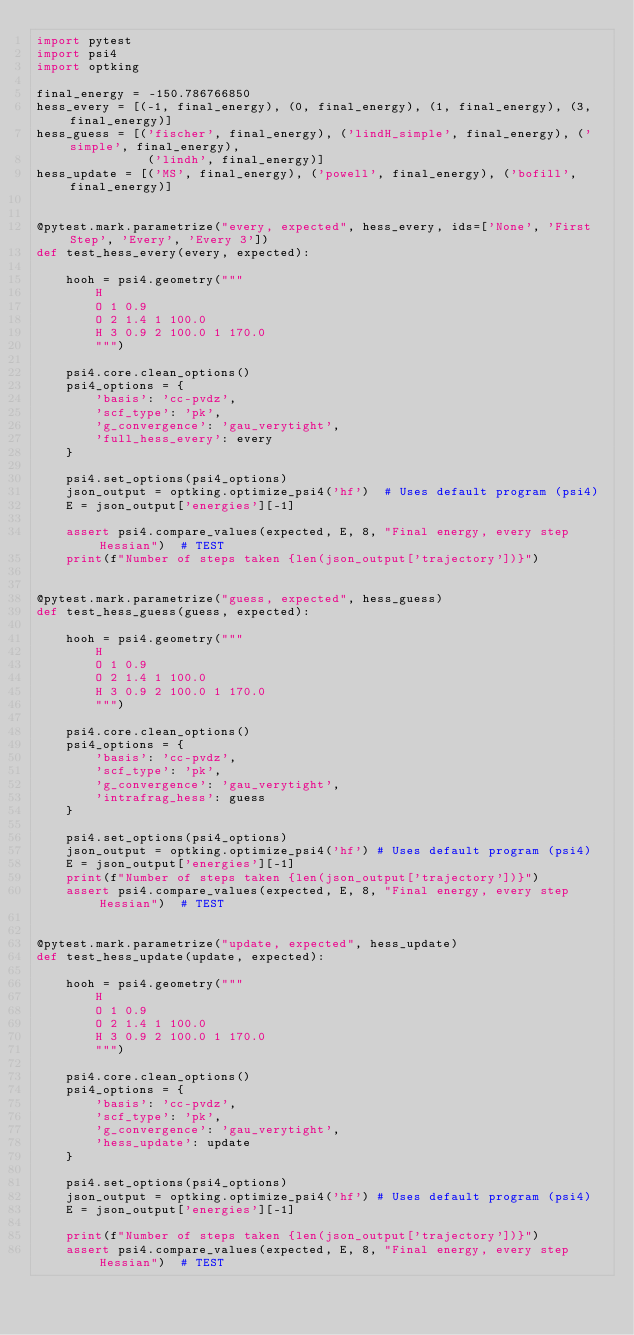<code> <loc_0><loc_0><loc_500><loc_500><_Python_>import pytest
import psi4
import optking

final_energy = -150.786766850
hess_every = [(-1, final_energy), (0, final_energy), (1, final_energy), (3, final_energy)]
hess_guess = [('fischer', final_energy), ('lindH_simple', final_energy), ('simple', final_energy),
               ('lindh', final_energy)]
hess_update = [('MS', final_energy), ('powell', final_energy), ('bofill', final_energy)]


@pytest.mark.parametrize("every, expected", hess_every, ids=['None', 'First Step', 'Every', 'Every 3'])
def test_hess_every(every, expected):

    hooh = psi4.geometry("""
        H
        O 1 0.9
        O 2 1.4 1 100.0
        H 3 0.9 2 100.0 1 170.0
        """)
    
    psi4.core.clean_options()
    psi4_options = {
        'basis': 'cc-pvdz',
        'scf_type': 'pk',
        'g_convergence': 'gau_verytight',
        'full_hess_every': every
    }
    
    psi4.set_options(psi4_options)
    json_output = optking.optimize_psi4('hf')  # Uses default program (psi4)
    E = json_output['energies'][-1]
    
    assert psi4.compare_values(expected, E, 8, "Final energy, every step Hessian")  # TEST
    print(f"Number of steps taken {len(json_output['trajectory'])}")


@pytest.mark.parametrize("guess, expected", hess_guess)
def test_hess_guess(guess, expected):

    hooh = psi4.geometry("""
        H
        O 1 0.9
        O 2 1.4 1 100.0
        H 3 0.9 2 100.0 1 170.0
        """)

    psi4.core.clean_options()
    psi4_options = {
        'basis': 'cc-pvdz',
        'scf_type': 'pk',
        'g_convergence': 'gau_verytight',
        'intrafrag_hess': guess
    }

    psi4.set_options(psi4_options)
    json_output = optking.optimize_psi4('hf') # Uses default program (psi4)
    E = json_output['energies'][-1]
    print(f"Number of steps taken {len(json_output['trajectory'])}")
    assert psi4.compare_values(expected, E, 8, "Final energy, every step Hessian")  # TEST


@pytest.mark.parametrize("update, expected", hess_update)
def test_hess_update(update, expected):

    hooh = psi4.geometry("""
        H
        O 1 0.9
        O 2 1.4 1 100.0
        H 3 0.9 2 100.0 1 170.0
        """)

    psi4.core.clean_options()
    psi4_options = {
        'basis': 'cc-pvdz',
        'scf_type': 'pk',
        'g_convergence': 'gau_verytight', 
        'hess_update': update
    }

    psi4.set_options(psi4_options)
    json_output = optking.optimize_psi4('hf') # Uses default program (psi4)
    E = json_output['energies'][-1]
    
    print(f"Number of steps taken {len(json_output['trajectory'])}")
    assert psi4.compare_values(expected, E, 8, "Final energy, every step Hessian")  # TEST
</code> 